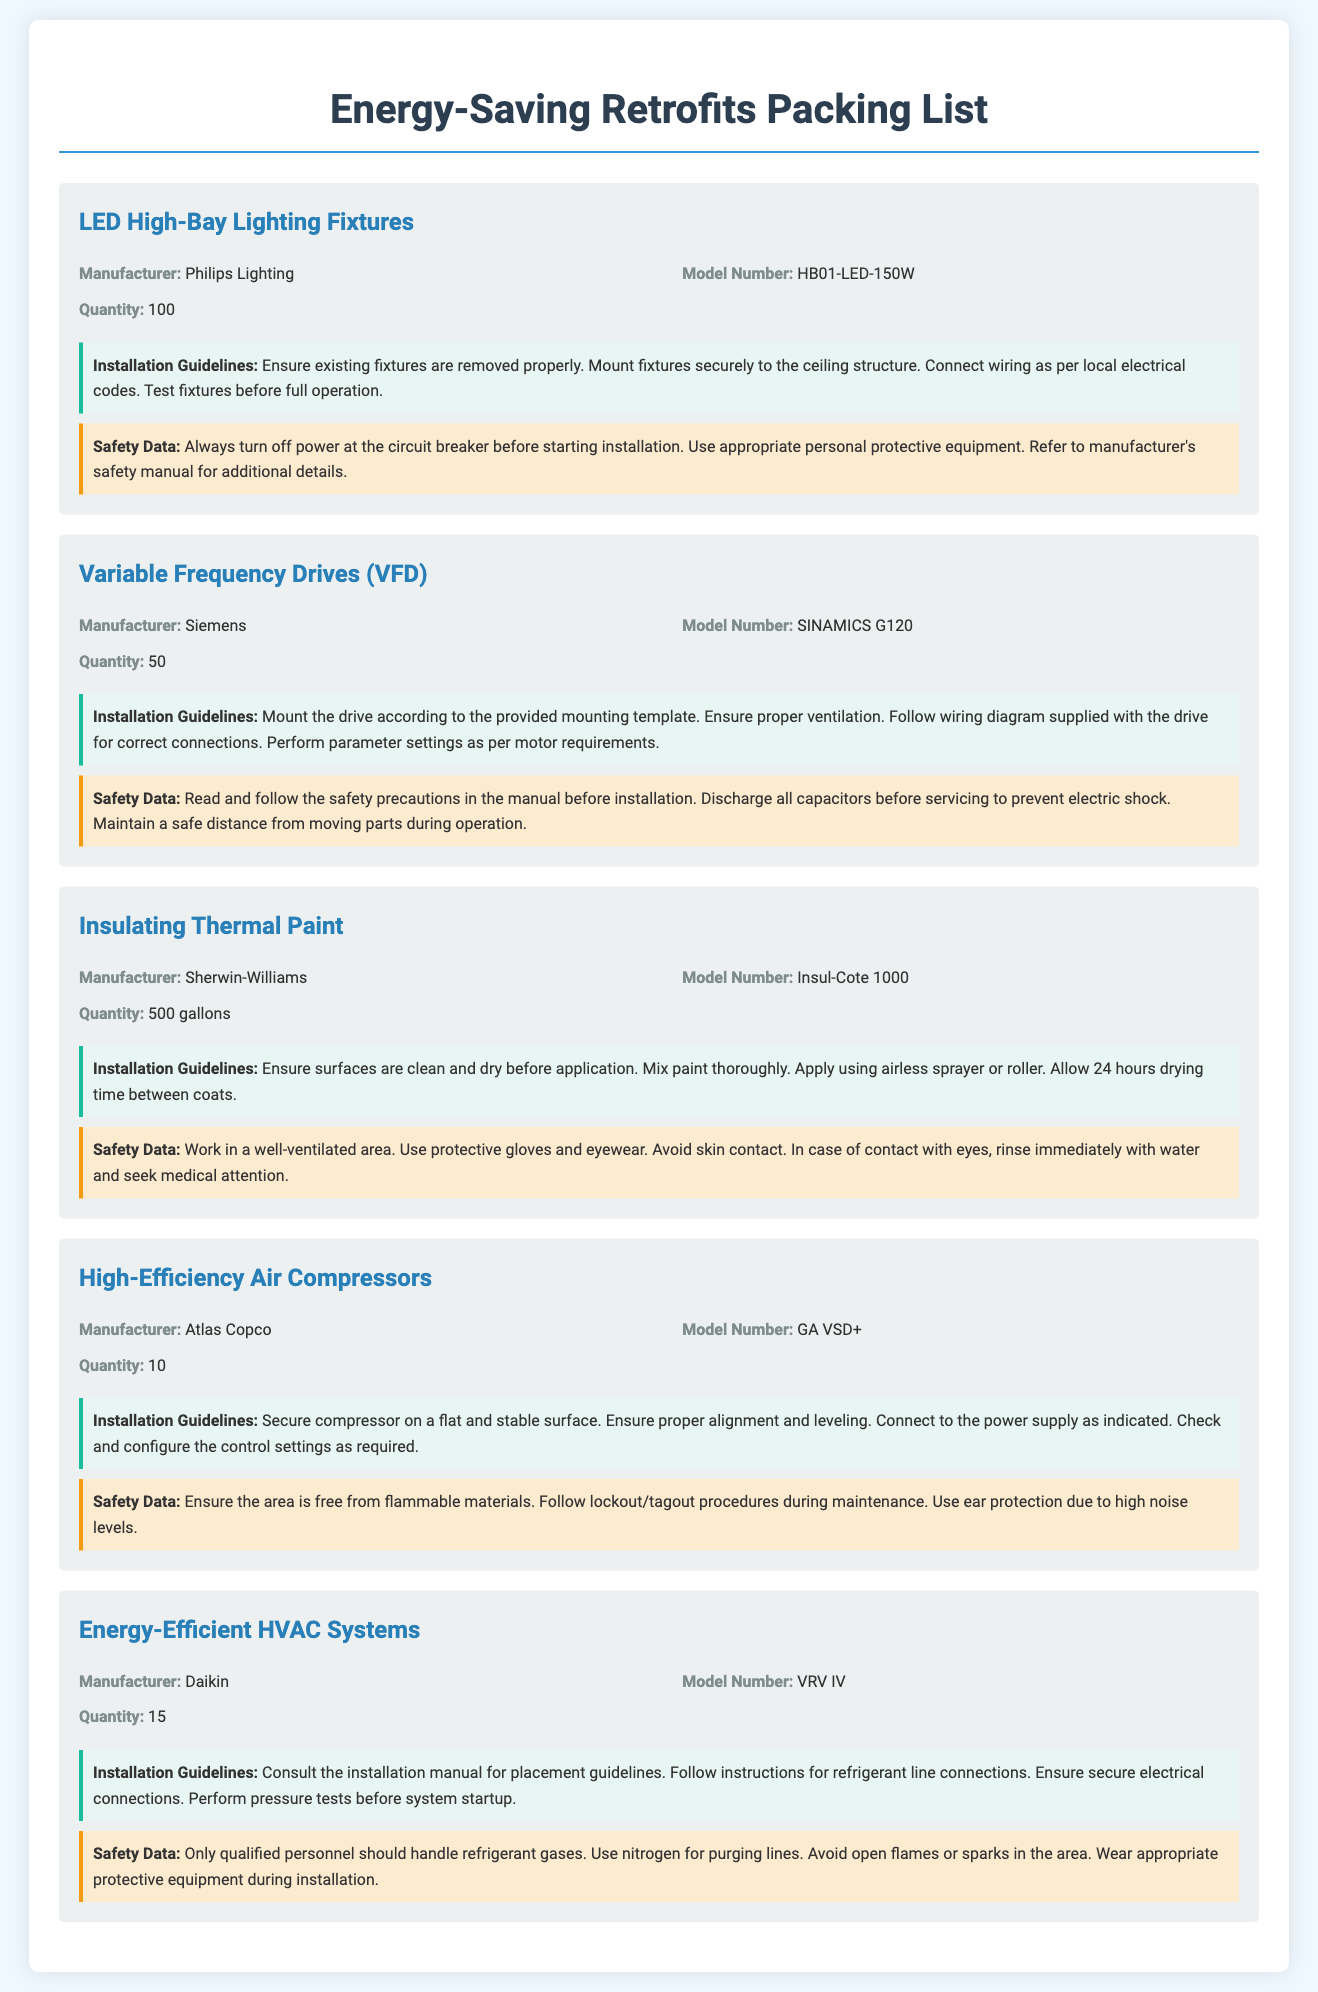What is the manufacturer of the LED High-Bay Lighting Fixtures? The manufacturer information is explicitly specified under each item in the document.
Answer: Philips Lighting How many Variable Frequency Drives are included? The quantity can be found in the description of the respective item in the document.
Answer: 50 What is the model number of the Insulating Thermal Paint? The model number is listed with each item, helping to identify the specific product.
Answer: Insul-Cote 1000 What are the safety precautions for the High-Efficiency Air Compressors? Safety data is provided for each item, outlining necessary precautions.
Answer: Ensure the area is free from flammable materials What is the installation guideline for the Energy-Efficient HVAC Systems? Installation guidelines detail the necessary steps for proper setup of each item.
Answer: Consult the installation manual for placement guidelines Which item requires 500 gallons? This requires cross-referencing item details to find the specific quantity associated with an item.
Answer: Insulating Thermal Paint How many LED High-Bay Lighting Fixtures are there? This information can be found in the quantity listed for that specific item.
Answer: 100 What is emphasized in the safety data for Variable Frequency Drives? Safety data details important safety measures related to installation and usage, indicating potential hazards.
Answer: Read and follow the safety precautions in the manual before installation What type of personal protective equipment is recommended for installing LED lights? The safety section provides specific recommendations for personal protective gear.
Answer: Appropriate personal protective equipment 